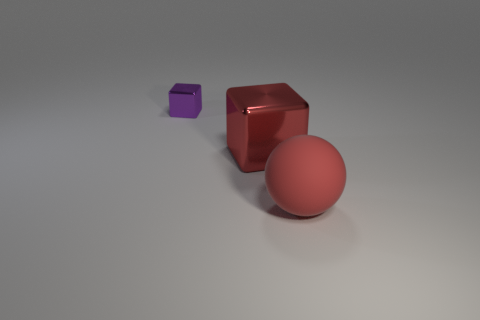Is there any other thing that has the same size as the purple object?
Your response must be concise. No. There is a thing that is the same material as the red block; what is its color?
Give a very brief answer. Purple. How many shiny things are big red spheres or yellow things?
Offer a very short reply. 0. Are the red ball and the small thing made of the same material?
Give a very brief answer. No. There is a purple thing to the left of the large red matte sphere; what shape is it?
Offer a very short reply. Cube. There is a metal block on the right side of the purple metal object; are there any red metal blocks that are behind it?
Offer a terse response. No. Are there any red balls that have the same size as the purple metal object?
Ensure brevity in your answer.  No. Do the metallic object that is left of the red metal block and the big block have the same color?
Your answer should be very brief. No. The red matte object is what size?
Give a very brief answer. Large. There is a shiny block that is behind the cube to the right of the small purple cube; what is its size?
Ensure brevity in your answer.  Small. 